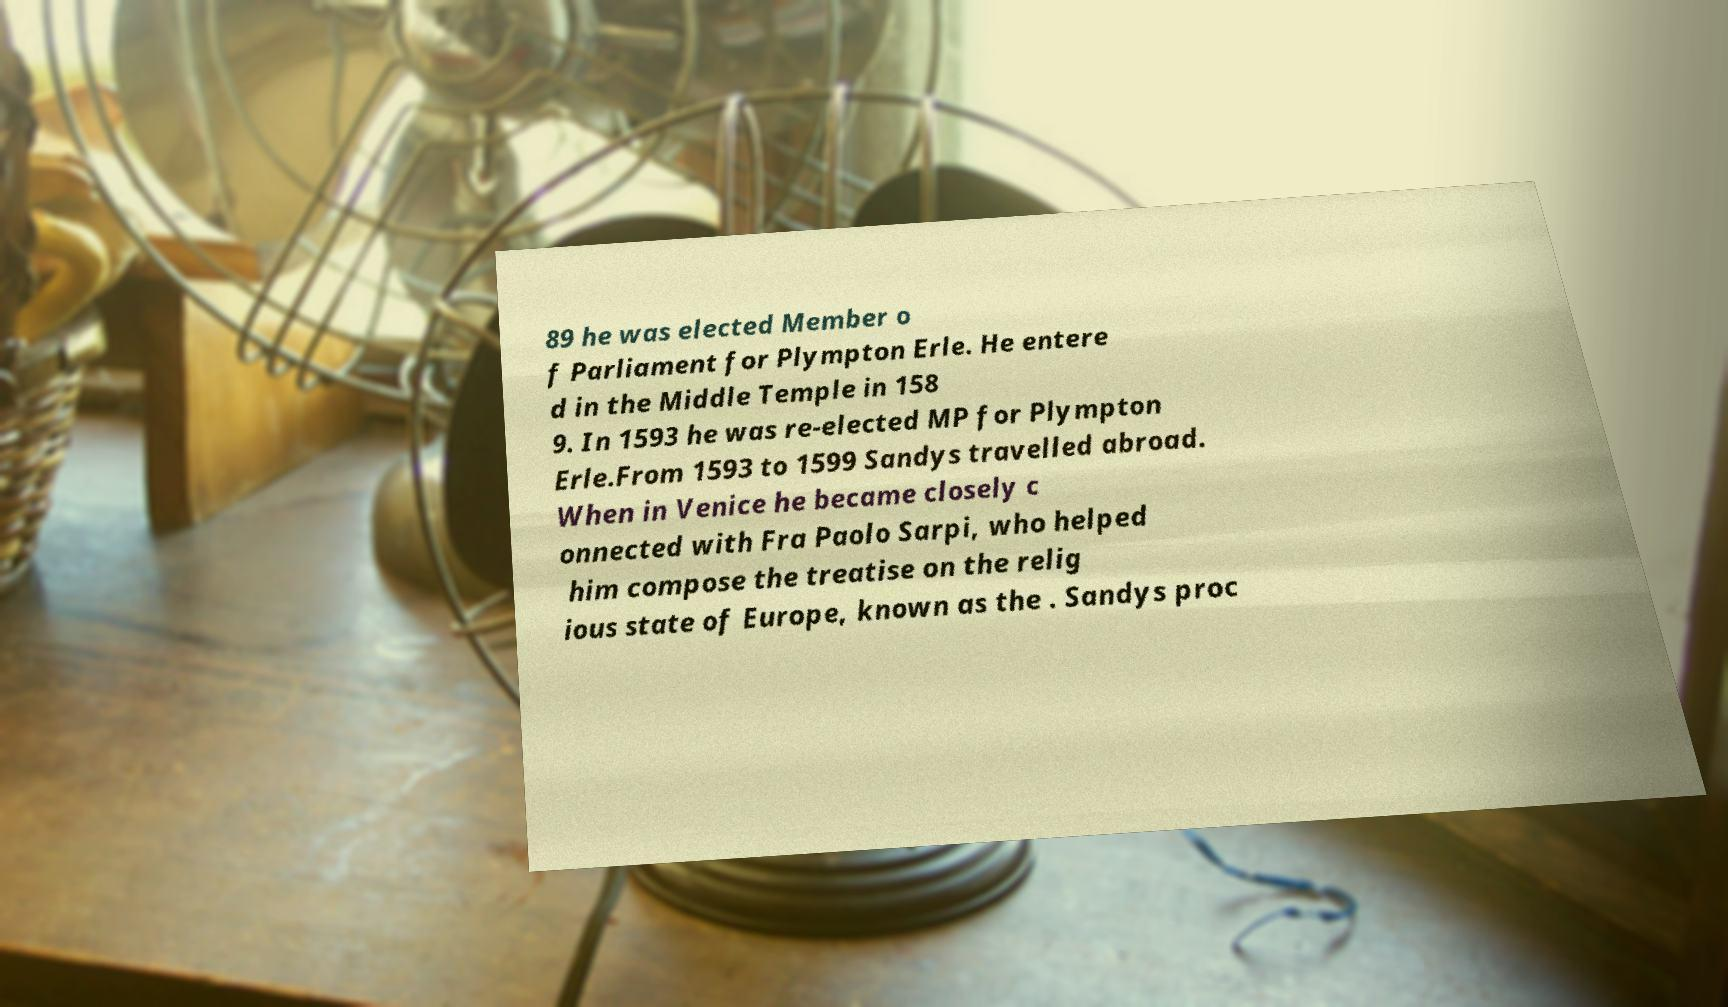Could you extract and type out the text from this image? 89 he was elected Member o f Parliament for Plympton Erle. He entere d in the Middle Temple in 158 9. In 1593 he was re-elected MP for Plympton Erle.From 1593 to 1599 Sandys travelled abroad. When in Venice he became closely c onnected with Fra Paolo Sarpi, who helped him compose the treatise on the relig ious state of Europe, known as the . Sandys proc 